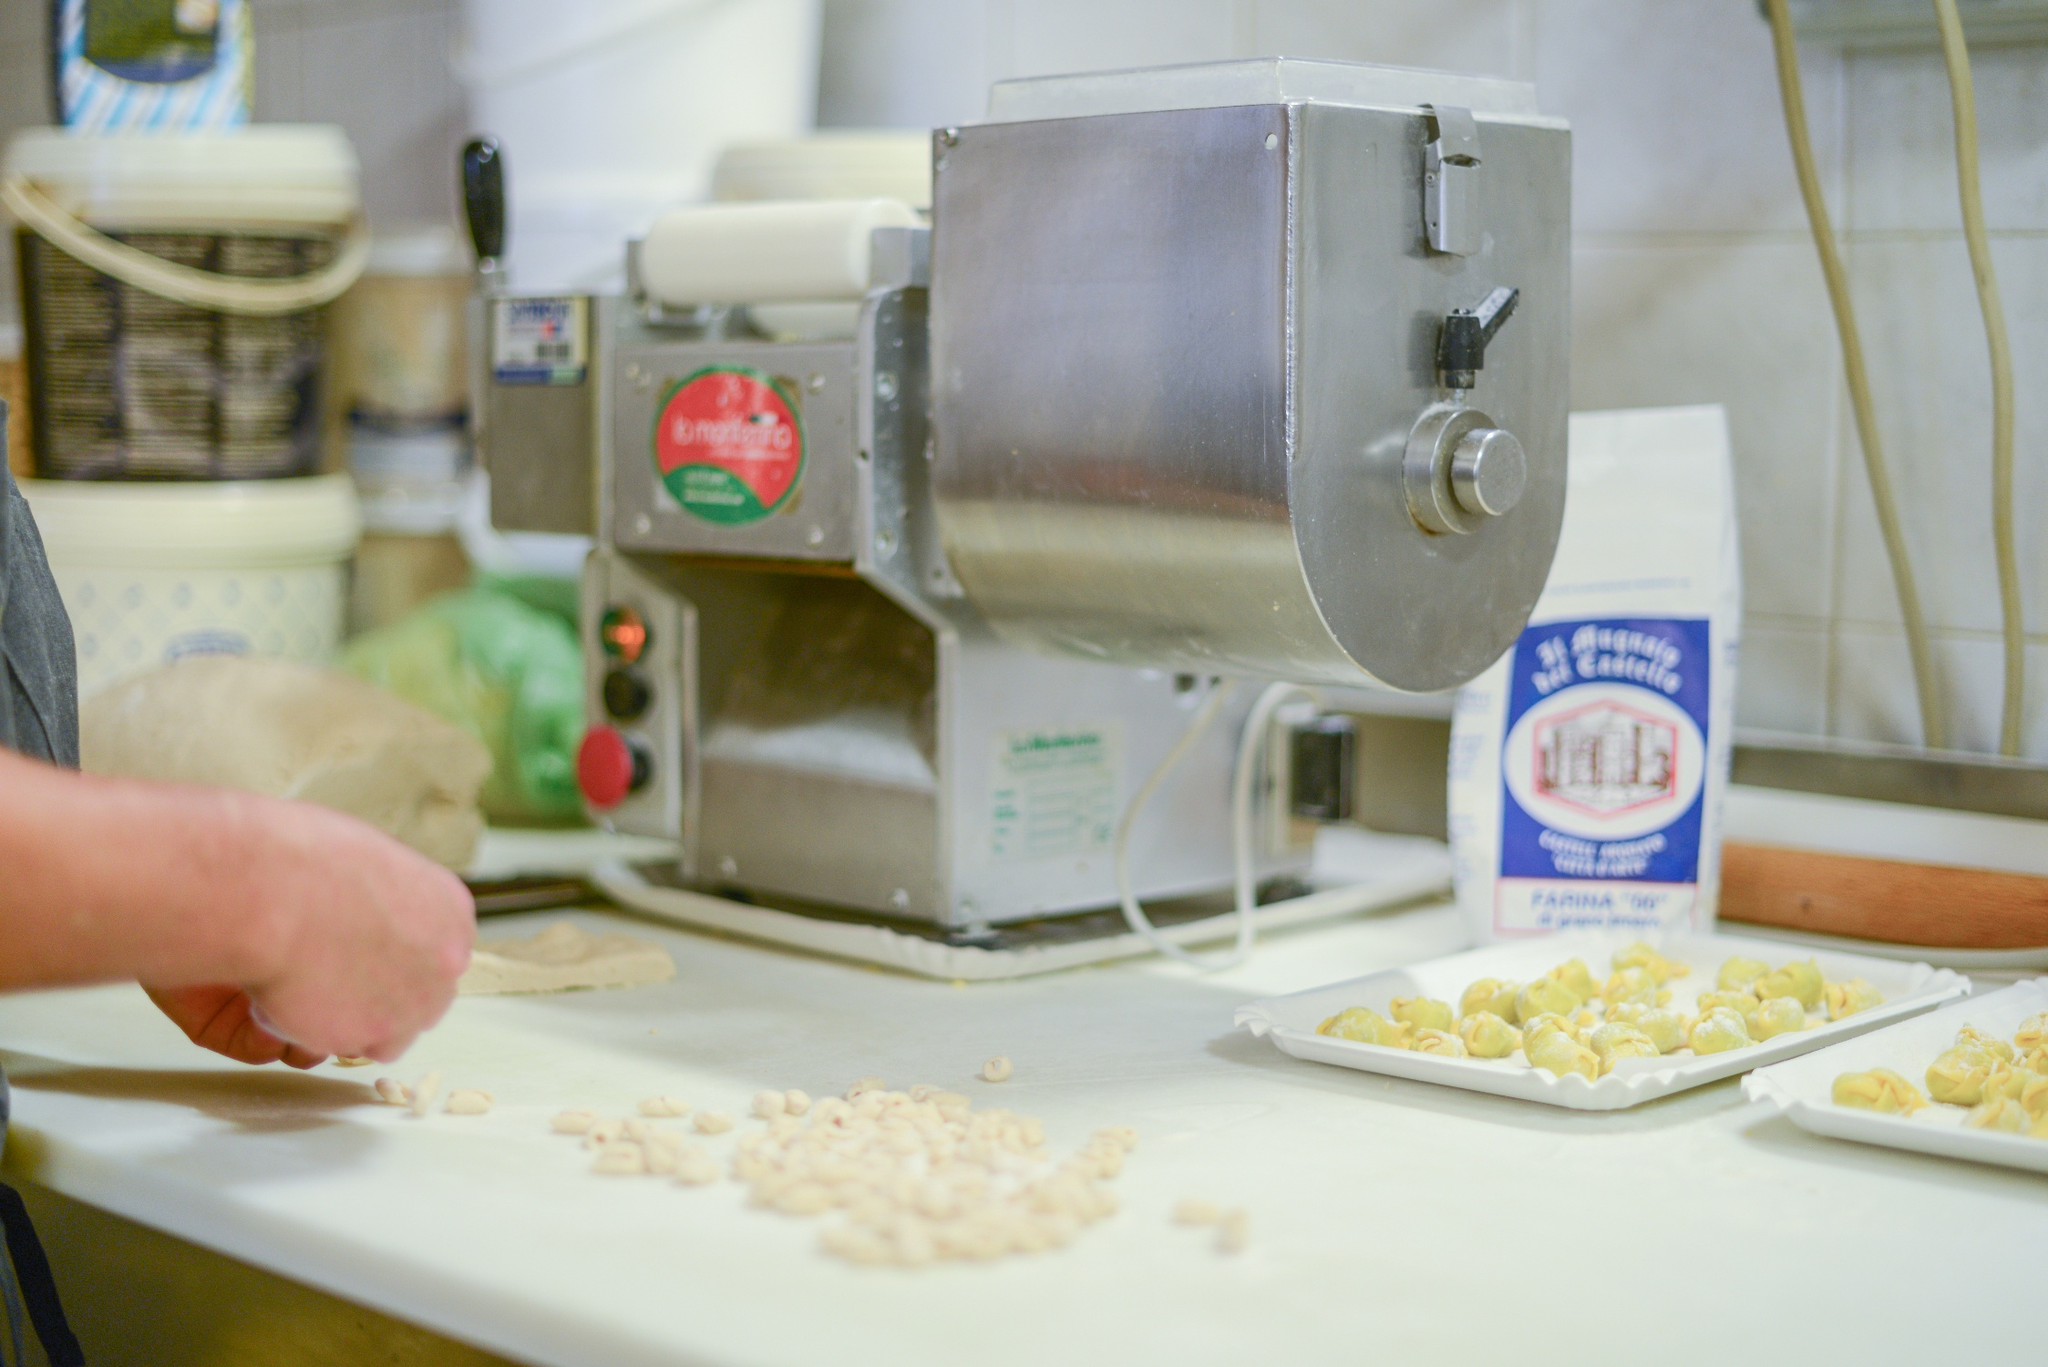Describe a cozy winter evening scenario in this kitchen. On a cozy winter evening, this kitchen transforms into a haven of warmth and comfort. The cold air from outside is kept at bay as the scents of simmering sauce and baking bread fill the air. A pot of hearty minestrone soup bubbles gently on the stove, while the pasta machine, with its familiar hum, rolls out dough for fresh ravioli. The white tiled backdrop and shelves offer a clean and organized space, making the kitchen feel cozy and inviting. Soft lighting casts a warm glow on the countertop, where flour dusts the surface and the beginnings of a family meal take shape. The scene is a perfect blend of culinary artistry and homely ambiance, making this kitchen the heart of the home.  What kind of event or special occasion might be taking place here? This scene might be set during a special family gathering or a pasta-making class. Perhaps it’s a Sunday afternoon where family members come together, each taking part in the age-old tradition of making pasta from scratch. Alternatively, it might be a professional cooking class, where budding chefs gather to learn the intricacies of pasta-making from a seasoned expert. The focus on culinary tools, fresh ingredients, and the neatly organized setting suggests an event where the joy of cooking is shared and celebrated. 